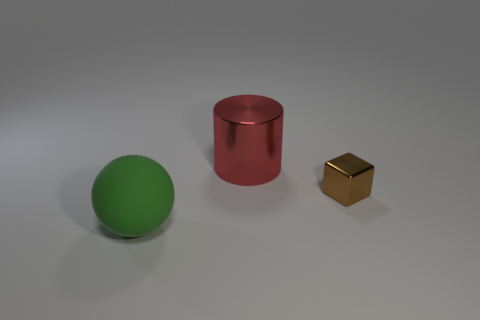Is the number of red metallic objects less than the number of shiny things?
Your answer should be very brief. Yes. Is the material of the large object behind the large matte thing the same as the thing on the right side of the red metal cylinder?
Ensure brevity in your answer.  Yes. Are there fewer large shiny objects that are to the left of the large green object than tiny gray matte spheres?
Your answer should be very brief. No. There is a metallic thing behind the tiny brown shiny object; how many objects are to the left of it?
Provide a short and direct response. 1. What is the size of the object that is in front of the large metal cylinder and to the left of the tiny brown cube?
Ensure brevity in your answer.  Large. Are there any other things that have the same material as the large green object?
Your answer should be compact. No. Are the large cylinder and the thing that is to the right of the big cylinder made of the same material?
Provide a short and direct response. Yes. Is the number of green matte spheres right of the rubber ball less than the number of large red cylinders behind the cube?
Provide a short and direct response. Yes. What material is the large thing behind the green rubber sphere?
Give a very brief answer. Metal. There is a object that is on the left side of the tiny thing and in front of the red metal cylinder; what color is it?
Give a very brief answer. Green. 